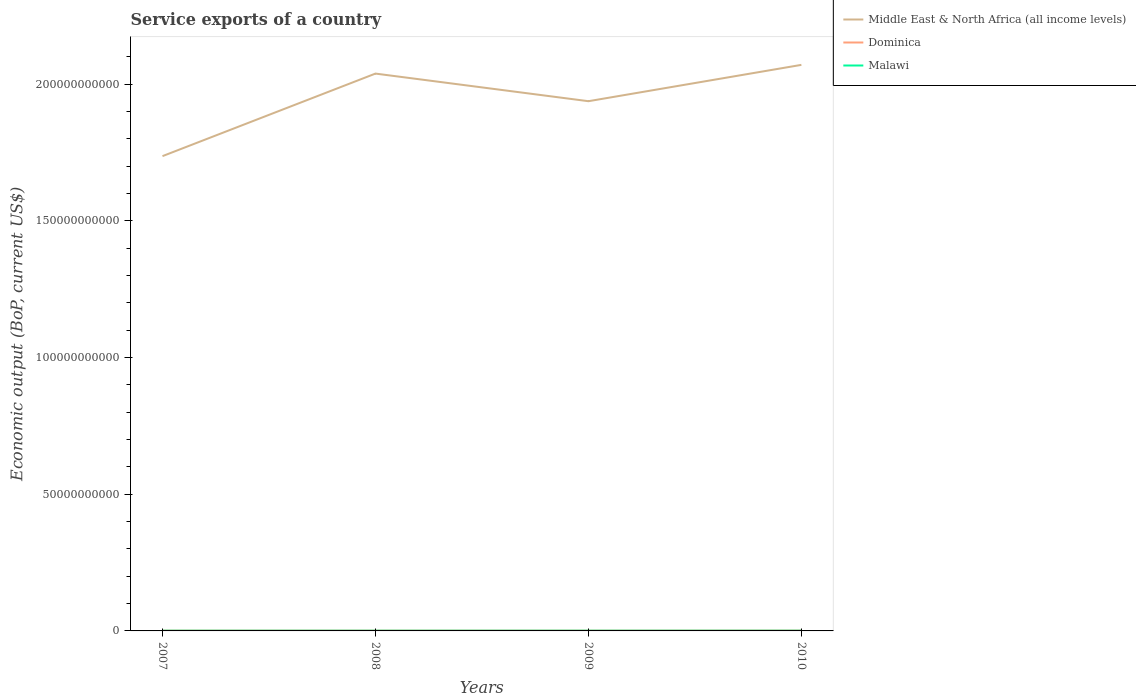Does the line corresponding to Middle East & North Africa (all income levels) intersect with the line corresponding to Malawi?
Your answer should be very brief. No. Is the number of lines equal to the number of legend labels?
Your response must be concise. Yes. Across all years, what is the maximum service exports in Middle East & North Africa (all income levels)?
Your answer should be very brief. 1.74e+11. In which year was the service exports in Malawi maximum?
Keep it short and to the point. 2007. What is the total service exports in Dominica in the graph?
Provide a succinct answer. -2.80e+07. What is the difference between the highest and the second highest service exports in Malawi?
Give a very brief answer. 8.65e+06. What is the difference between the highest and the lowest service exports in Middle East & North Africa (all income levels)?
Give a very brief answer. 2. How many lines are there?
Give a very brief answer. 3. Does the graph contain any zero values?
Give a very brief answer. No. Where does the legend appear in the graph?
Give a very brief answer. Top right. What is the title of the graph?
Your answer should be very brief. Service exports of a country. Does "Mauritania" appear as one of the legend labels in the graph?
Offer a terse response. No. What is the label or title of the Y-axis?
Ensure brevity in your answer.  Economic output (BoP, current US$). What is the Economic output (BoP, current US$) in Middle East & North Africa (all income levels) in 2007?
Ensure brevity in your answer.  1.74e+11. What is the Economic output (BoP, current US$) of Dominica in 2007?
Your answer should be very brief. 1.09e+08. What is the Economic output (BoP, current US$) of Malawi in 2007?
Provide a succinct answer. 7.40e+07. What is the Economic output (BoP, current US$) in Middle East & North Africa (all income levels) in 2008?
Provide a short and direct response. 2.04e+11. What is the Economic output (BoP, current US$) of Dominica in 2008?
Provide a short and direct response. 1.13e+08. What is the Economic output (BoP, current US$) in Malawi in 2008?
Your response must be concise. 7.44e+07. What is the Economic output (BoP, current US$) of Middle East & North Africa (all income levels) in 2009?
Offer a terse response. 1.94e+11. What is the Economic output (BoP, current US$) in Dominica in 2009?
Make the answer very short. 1.11e+08. What is the Economic output (BoP, current US$) in Malawi in 2009?
Make the answer very short. 7.91e+07. What is the Economic output (BoP, current US$) of Middle East & North Africa (all income levels) in 2010?
Provide a short and direct response. 2.07e+11. What is the Economic output (BoP, current US$) in Dominica in 2010?
Offer a terse response. 1.37e+08. What is the Economic output (BoP, current US$) of Malawi in 2010?
Keep it short and to the point. 8.27e+07. Across all years, what is the maximum Economic output (BoP, current US$) in Middle East & North Africa (all income levels)?
Keep it short and to the point. 2.07e+11. Across all years, what is the maximum Economic output (BoP, current US$) of Dominica?
Offer a terse response. 1.37e+08. Across all years, what is the maximum Economic output (BoP, current US$) in Malawi?
Make the answer very short. 8.27e+07. Across all years, what is the minimum Economic output (BoP, current US$) in Middle East & North Africa (all income levels)?
Your answer should be very brief. 1.74e+11. Across all years, what is the minimum Economic output (BoP, current US$) in Dominica?
Ensure brevity in your answer.  1.09e+08. Across all years, what is the minimum Economic output (BoP, current US$) in Malawi?
Your answer should be very brief. 7.40e+07. What is the total Economic output (BoP, current US$) in Middle East & North Africa (all income levels) in the graph?
Provide a succinct answer. 7.79e+11. What is the total Economic output (BoP, current US$) in Dominica in the graph?
Make the answer very short. 4.70e+08. What is the total Economic output (BoP, current US$) of Malawi in the graph?
Offer a very short reply. 3.10e+08. What is the difference between the Economic output (BoP, current US$) of Middle East & North Africa (all income levels) in 2007 and that in 2008?
Make the answer very short. -3.02e+1. What is the difference between the Economic output (BoP, current US$) of Dominica in 2007 and that in 2008?
Provide a succinct answer. -4.02e+06. What is the difference between the Economic output (BoP, current US$) of Malawi in 2007 and that in 2008?
Ensure brevity in your answer.  -3.88e+05. What is the difference between the Economic output (BoP, current US$) of Middle East & North Africa (all income levels) in 2007 and that in 2009?
Ensure brevity in your answer.  -2.01e+1. What is the difference between the Economic output (BoP, current US$) in Dominica in 2007 and that in 2009?
Ensure brevity in your answer.  -2.31e+06. What is the difference between the Economic output (BoP, current US$) of Malawi in 2007 and that in 2009?
Offer a very short reply. -5.08e+06. What is the difference between the Economic output (BoP, current US$) of Middle East & North Africa (all income levels) in 2007 and that in 2010?
Your response must be concise. -3.34e+1. What is the difference between the Economic output (BoP, current US$) in Dominica in 2007 and that in 2010?
Your response must be concise. -2.80e+07. What is the difference between the Economic output (BoP, current US$) of Malawi in 2007 and that in 2010?
Provide a short and direct response. -8.65e+06. What is the difference between the Economic output (BoP, current US$) in Middle East & North Africa (all income levels) in 2008 and that in 2009?
Keep it short and to the point. 1.01e+1. What is the difference between the Economic output (BoP, current US$) of Dominica in 2008 and that in 2009?
Make the answer very short. 1.71e+06. What is the difference between the Economic output (BoP, current US$) of Malawi in 2008 and that in 2009?
Offer a very short reply. -4.69e+06. What is the difference between the Economic output (BoP, current US$) in Middle East & North Africa (all income levels) in 2008 and that in 2010?
Keep it short and to the point. -3.19e+09. What is the difference between the Economic output (BoP, current US$) of Dominica in 2008 and that in 2010?
Your answer should be very brief. -2.40e+07. What is the difference between the Economic output (BoP, current US$) in Malawi in 2008 and that in 2010?
Give a very brief answer. -8.26e+06. What is the difference between the Economic output (BoP, current US$) of Middle East & North Africa (all income levels) in 2009 and that in 2010?
Ensure brevity in your answer.  -1.33e+1. What is the difference between the Economic output (BoP, current US$) in Dominica in 2009 and that in 2010?
Your answer should be compact. -2.57e+07. What is the difference between the Economic output (BoP, current US$) in Malawi in 2009 and that in 2010?
Provide a short and direct response. -3.57e+06. What is the difference between the Economic output (BoP, current US$) of Middle East & North Africa (all income levels) in 2007 and the Economic output (BoP, current US$) of Dominica in 2008?
Your answer should be compact. 1.74e+11. What is the difference between the Economic output (BoP, current US$) of Middle East & North Africa (all income levels) in 2007 and the Economic output (BoP, current US$) of Malawi in 2008?
Offer a very short reply. 1.74e+11. What is the difference between the Economic output (BoP, current US$) of Dominica in 2007 and the Economic output (BoP, current US$) of Malawi in 2008?
Keep it short and to the point. 3.44e+07. What is the difference between the Economic output (BoP, current US$) of Middle East & North Africa (all income levels) in 2007 and the Economic output (BoP, current US$) of Dominica in 2009?
Ensure brevity in your answer.  1.74e+11. What is the difference between the Economic output (BoP, current US$) of Middle East & North Africa (all income levels) in 2007 and the Economic output (BoP, current US$) of Malawi in 2009?
Give a very brief answer. 1.74e+11. What is the difference between the Economic output (BoP, current US$) in Dominica in 2007 and the Economic output (BoP, current US$) in Malawi in 2009?
Offer a terse response. 2.97e+07. What is the difference between the Economic output (BoP, current US$) in Middle East & North Africa (all income levels) in 2007 and the Economic output (BoP, current US$) in Dominica in 2010?
Ensure brevity in your answer.  1.74e+11. What is the difference between the Economic output (BoP, current US$) in Middle East & North Africa (all income levels) in 2007 and the Economic output (BoP, current US$) in Malawi in 2010?
Offer a terse response. 1.74e+11. What is the difference between the Economic output (BoP, current US$) of Dominica in 2007 and the Economic output (BoP, current US$) of Malawi in 2010?
Your answer should be very brief. 2.62e+07. What is the difference between the Economic output (BoP, current US$) in Middle East & North Africa (all income levels) in 2008 and the Economic output (BoP, current US$) in Dominica in 2009?
Ensure brevity in your answer.  2.04e+11. What is the difference between the Economic output (BoP, current US$) of Middle East & North Africa (all income levels) in 2008 and the Economic output (BoP, current US$) of Malawi in 2009?
Your response must be concise. 2.04e+11. What is the difference between the Economic output (BoP, current US$) in Dominica in 2008 and the Economic output (BoP, current US$) in Malawi in 2009?
Give a very brief answer. 3.38e+07. What is the difference between the Economic output (BoP, current US$) in Middle East & North Africa (all income levels) in 2008 and the Economic output (BoP, current US$) in Dominica in 2010?
Provide a short and direct response. 2.04e+11. What is the difference between the Economic output (BoP, current US$) of Middle East & North Africa (all income levels) in 2008 and the Economic output (BoP, current US$) of Malawi in 2010?
Provide a succinct answer. 2.04e+11. What is the difference between the Economic output (BoP, current US$) in Dominica in 2008 and the Economic output (BoP, current US$) in Malawi in 2010?
Offer a terse response. 3.02e+07. What is the difference between the Economic output (BoP, current US$) in Middle East & North Africa (all income levels) in 2009 and the Economic output (BoP, current US$) in Dominica in 2010?
Your answer should be compact. 1.94e+11. What is the difference between the Economic output (BoP, current US$) of Middle East & North Africa (all income levels) in 2009 and the Economic output (BoP, current US$) of Malawi in 2010?
Offer a terse response. 1.94e+11. What is the difference between the Economic output (BoP, current US$) in Dominica in 2009 and the Economic output (BoP, current US$) in Malawi in 2010?
Your response must be concise. 2.85e+07. What is the average Economic output (BoP, current US$) of Middle East & North Africa (all income levels) per year?
Offer a terse response. 1.95e+11. What is the average Economic output (BoP, current US$) of Dominica per year?
Provide a succinct answer. 1.17e+08. What is the average Economic output (BoP, current US$) in Malawi per year?
Your answer should be compact. 7.75e+07. In the year 2007, what is the difference between the Economic output (BoP, current US$) of Middle East & North Africa (all income levels) and Economic output (BoP, current US$) of Dominica?
Your answer should be very brief. 1.74e+11. In the year 2007, what is the difference between the Economic output (BoP, current US$) of Middle East & North Africa (all income levels) and Economic output (BoP, current US$) of Malawi?
Your response must be concise. 1.74e+11. In the year 2007, what is the difference between the Economic output (BoP, current US$) of Dominica and Economic output (BoP, current US$) of Malawi?
Your response must be concise. 3.48e+07. In the year 2008, what is the difference between the Economic output (BoP, current US$) in Middle East & North Africa (all income levels) and Economic output (BoP, current US$) in Dominica?
Make the answer very short. 2.04e+11. In the year 2008, what is the difference between the Economic output (BoP, current US$) in Middle East & North Africa (all income levels) and Economic output (BoP, current US$) in Malawi?
Offer a terse response. 2.04e+11. In the year 2008, what is the difference between the Economic output (BoP, current US$) of Dominica and Economic output (BoP, current US$) of Malawi?
Your answer should be very brief. 3.84e+07. In the year 2009, what is the difference between the Economic output (BoP, current US$) of Middle East & North Africa (all income levels) and Economic output (BoP, current US$) of Dominica?
Ensure brevity in your answer.  1.94e+11. In the year 2009, what is the difference between the Economic output (BoP, current US$) in Middle East & North Africa (all income levels) and Economic output (BoP, current US$) in Malawi?
Provide a short and direct response. 1.94e+11. In the year 2009, what is the difference between the Economic output (BoP, current US$) of Dominica and Economic output (BoP, current US$) of Malawi?
Your response must be concise. 3.20e+07. In the year 2010, what is the difference between the Economic output (BoP, current US$) of Middle East & North Africa (all income levels) and Economic output (BoP, current US$) of Dominica?
Offer a terse response. 2.07e+11. In the year 2010, what is the difference between the Economic output (BoP, current US$) in Middle East & North Africa (all income levels) and Economic output (BoP, current US$) in Malawi?
Keep it short and to the point. 2.07e+11. In the year 2010, what is the difference between the Economic output (BoP, current US$) in Dominica and Economic output (BoP, current US$) in Malawi?
Give a very brief answer. 5.42e+07. What is the ratio of the Economic output (BoP, current US$) of Middle East & North Africa (all income levels) in 2007 to that in 2008?
Give a very brief answer. 0.85. What is the ratio of the Economic output (BoP, current US$) in Dominica in 2007 to that in 2008?
Keep it short and to the point. 0.96. What is the ratio of the Economic output (BoP, current US$) in Malawi in 2007 to that in 2008?
Provide a succinct answer. 0.99. What is the ratio of the Economic output (BoP, current US$) in Middle East & North Africa (all income levels) in 2007 to that in 2009?
Your answer should be compact. 0.9. What is the ratio of the Economic output (BoP, current US$) in Dominica in 2007 to that in 2009?
Your answer should be very brief. 0.98. What is the ratio of the Economic output (BoP, current US$) in Malawi in 2007 to that in 2009?
Provide a short and direct response. 0.94. What is the ratio of the Economic output (BoP, current US$) in Middle East & North Africa (all income levels) in 2007 to that in 2010?
Make the answer very short. 0.84. What is the ratio of the Economic output (BoP, current US$) of Dominica in 2007 to that in 2010?
Your answer should be very brief. 0.8. What is the ratio of the Economic output (BoP, current US$) of Malawi in 2007 to that in 2010?
Your answer should be very brief. 0.9. What is the ratio of the Economic output (BoP, current US$) in Middle East & North Africa (all income levels) in 2008 to that in 2009?
Offer a terse response. 1.05. What is the ratio of the Economic output (BoP, current US$) of Dominica in 2008 to that in 2009?
Offer a terse response. 1.02. What is the ratio of the Economic output (BoP, current US$) of Malawi in 2008 to that in 2009?
Keep it short and to the point. 0.94. What is the ratio of the Economic output (BoP, current US$) of Middle East & North Africa (all income levels) in 2008 to that in 2010?
Your answer should be very brief. 0.98. What is the ratio of the Economic output (BoP, current US$) in Dominica in 2008 to that in 2010?
Provide a succinct answer. 0.82. What is the ratio of the Economic output (BoP, current US$) in Malawi in 2008 to that in 2010?
Your response must be concise. 0.9. What is the ratio of the Economic output (BoP, current US$) of Middle East & North Africa (all income levels) in 2009 to that in 2010?
Your answer should be very brief. 0.94. What is the ratio of the Economic output (BoP, current US$) of Dominica in 2009 to that in 2010?
Ensure brevity in your answer.  0.81. What is the ratio of the Economic output (BoP, current US$) of Malawi in 2009 to that in 2010?
Give a very brief answer. 0.96. What is the difference between the highest and the second highest Economic output (BoP, current US$) of Middle East & North Africa (all income levels)?
Provide a short and direct response. 3.19e+09. What is the difference between the highest and the second highest Economic output (BoP, current US$) of Dominica?
Make the answer very short. 2.40e+07. What is the difference between the highest and the second highest Economic output (BoP, current US$) in Malawi?
Your answer should be compact. 3.57e+06. What is the difference between the highest and the lowest Economic output (BoP, current US$) of Middle East & North Africa (all income levels)?
Provide a short and direct response. 3.34e+1. What is the difference between the highest and the lowest Economic output (BoP, current US$) of Dominica?
Keep it short and to the point. 2.80e+07. What is the difference between the highest and the lowest Economic output (BoP, current US$) in Malawi?
Your answer should be compact. 8.65e+06. 